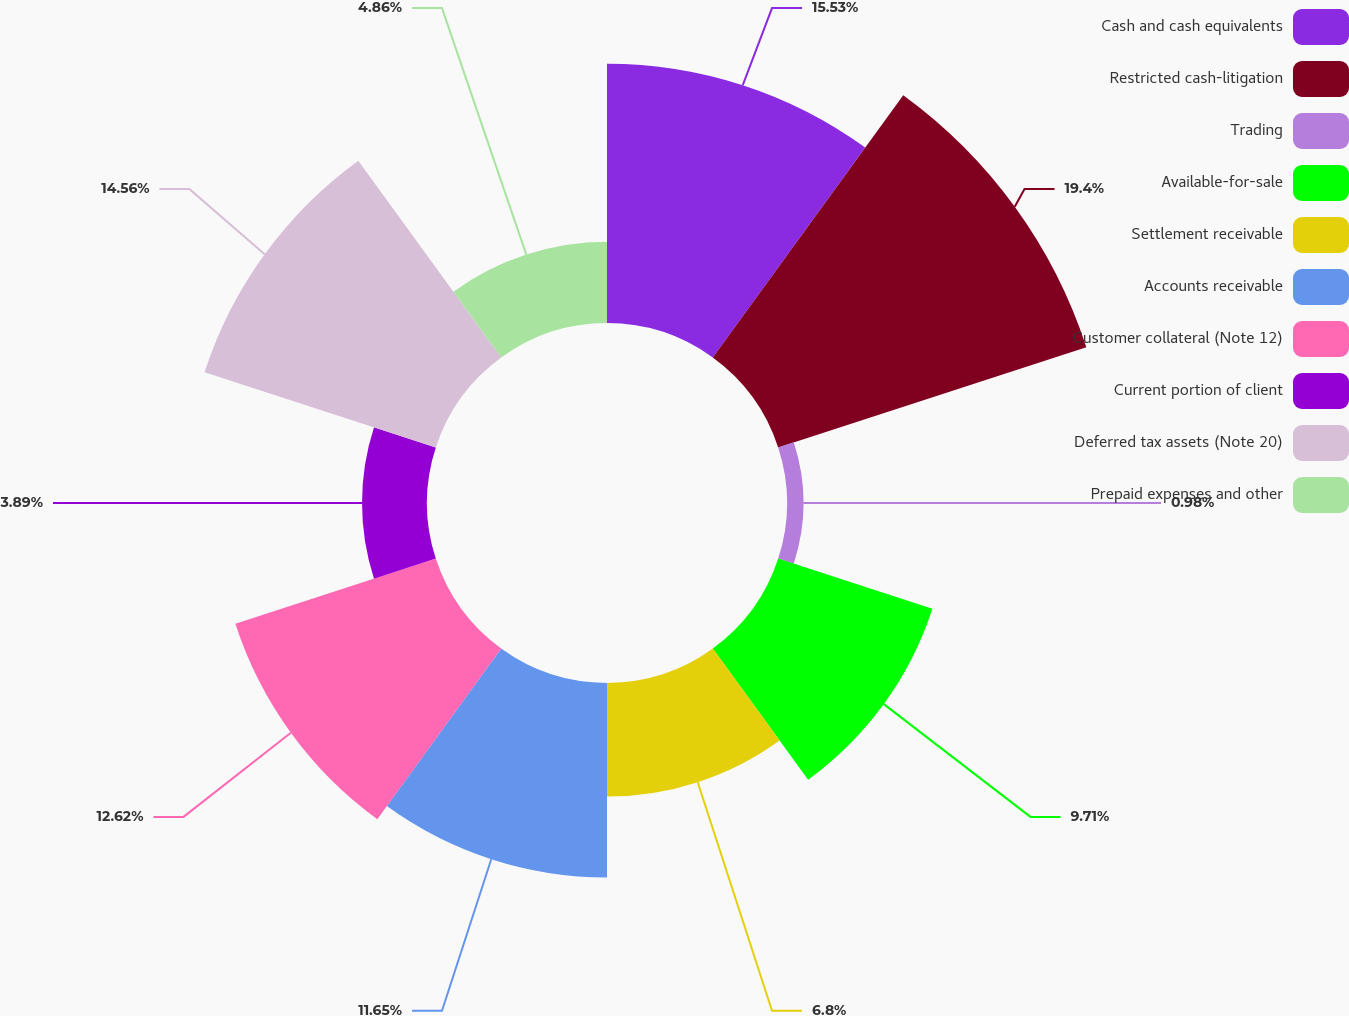Convert chart to OTSL. <chart><loc_0><loc_0><loc_500><loc_500><pie_chart><fcel>Cash and cash equivalents<fcel>Restricted cash-litigation<fcel>Trading<fcel>Available-for-sale<fcel>Settlement receivable<fcel>Accounts receivable<fcel>Customer collateral (Note 12)<fcel>Current portion of client<fcel>Deferred tax assets (Note 20)<fcel>Prepaid expenses and other<nl><fcel>15.53%<fcel>19.4%<fcel>0.98%<fcel>9.71%<fcel>6.8%<fcel>11.65%<fcel>12.62%<fcel>3.89%<fcel>14.56%<fcel>4.86%<nl></chart> 